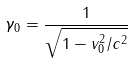Convert formula to latex. <formula><loc_0><loc_0><loc_500><loc_500>\gamma _ { 0 } = \frac { 1 } { \sqrt { 1 - v _ { 0 } ^ { 2 } / c ^ { 2 } } }</formula> 